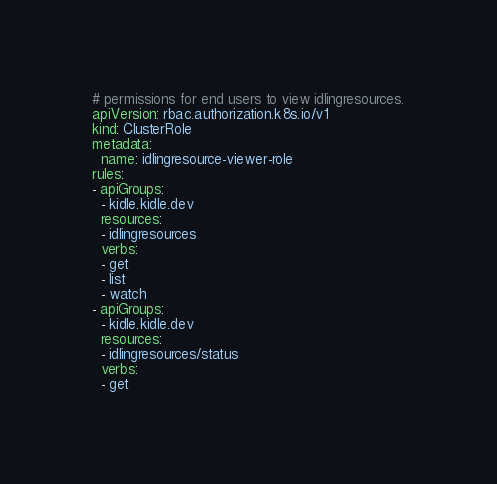<code> <loc_0><loc_0><loc_500><loc_500><_YAML_># permissions for end users to view idlingresources.
apiVersion: rbac.authorization.k8s.io/v1
kind: ClusterRole
metadata:
  name: idlingresource-viewer-role
rules:
- apiGroups:
  - kidle.kidle.dev
  resources:
  - idlingresources
  verbs:
  - get
  - list
  - watch
- apiGroups:
  - kidle.kidle.dev
  resources:
  - idlingresources/status
  verbs:
  - get
</code> 